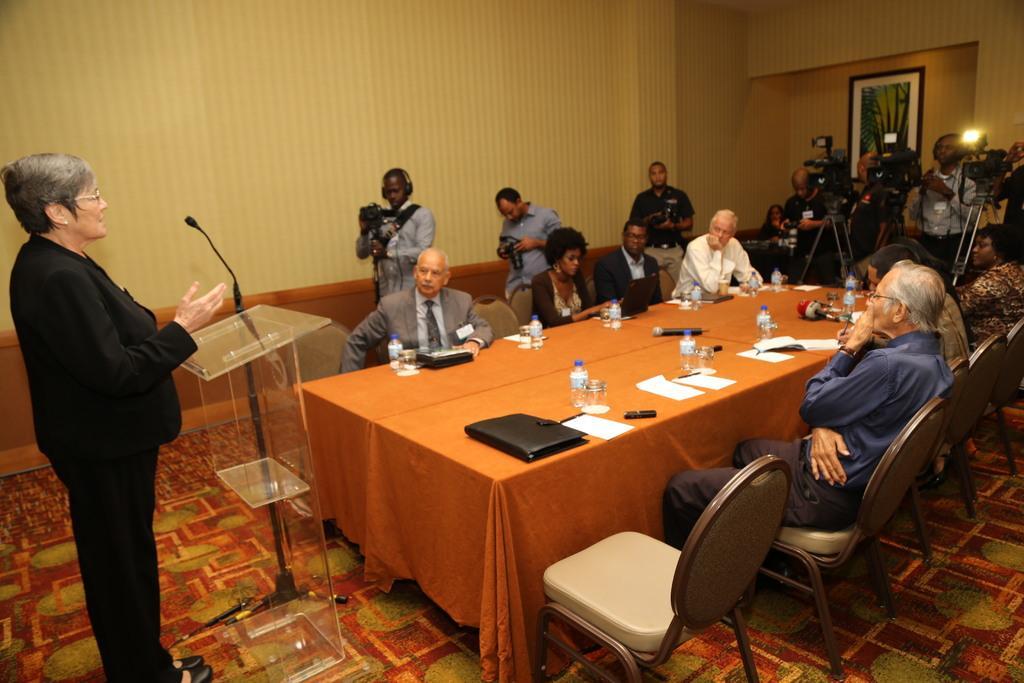How would you summarize this image in a sentence or two? Persons are sitting on the chair and on the table we have bottle,paper,file,glass and people are standing holding camera,on the wall photo frame,person is standing. 